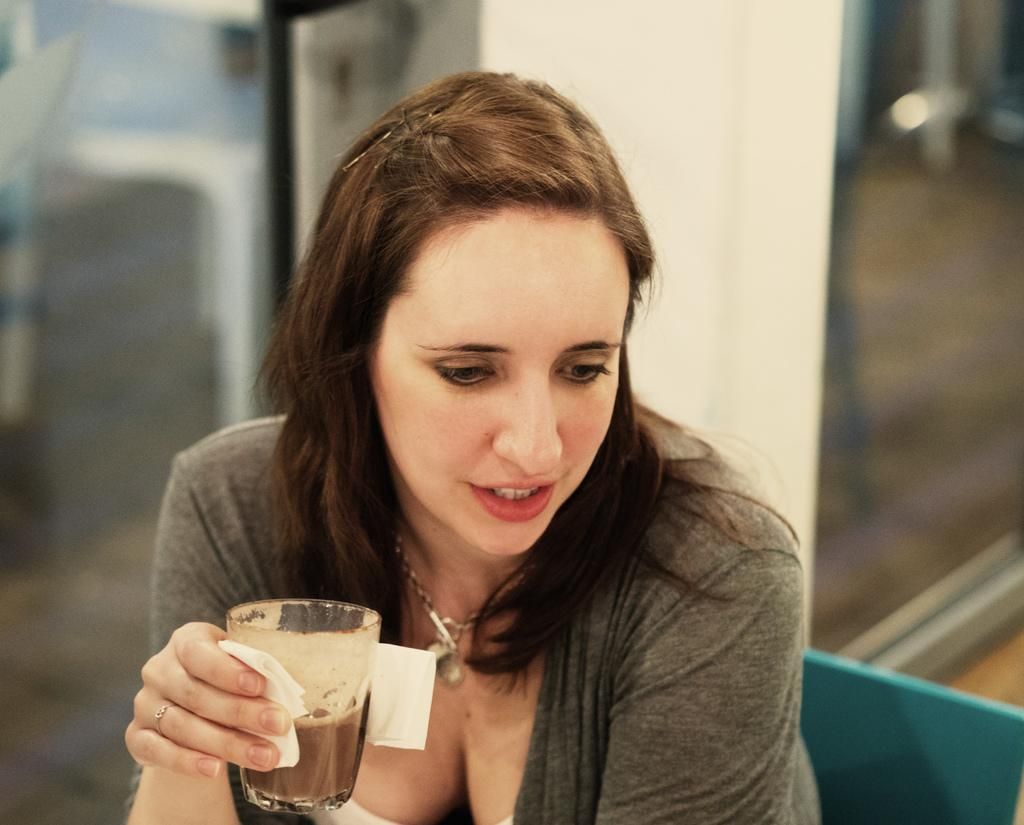What is the main subject of the picture? The main subject of the picture is a woman. Can you describe what the woman is wearing? The woman is wearing a locket and a t-shirt. What is the woman holding in the picture? The woman is holding a coffee glass. What is the woman's posture or position in the image? The woman is sitting on a chair. What architectural features can be seen in the background of the image? There is a glass partition and a pillar visible in the background. How many fingers can be seen holding the kitty in the image? There is no kitty present in the image, and therefore no fingers holding it. What type of net is visible in the background of the image? There is no net visible in the background of the image. 